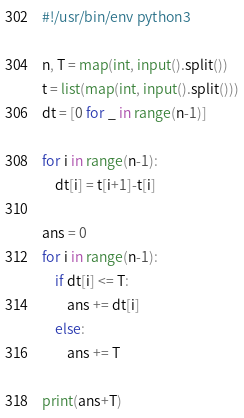<code> <loc_0><loc_0><loc_500><loc_500><_Python_>#!/usr/bin/env python3 

n, T = map(int, input().split())
t = list(map(int, input().split()))
dt = [0 for _ in range(n-1)]

for i in range(n-1):
    dt[i] = t[i+1]-t[i]

ans = 0 
for i in range(n-1):
    if dt[i] <= T:
        ans += dt[i]
    else:
        ans += T

print(ans+T)
</code> 